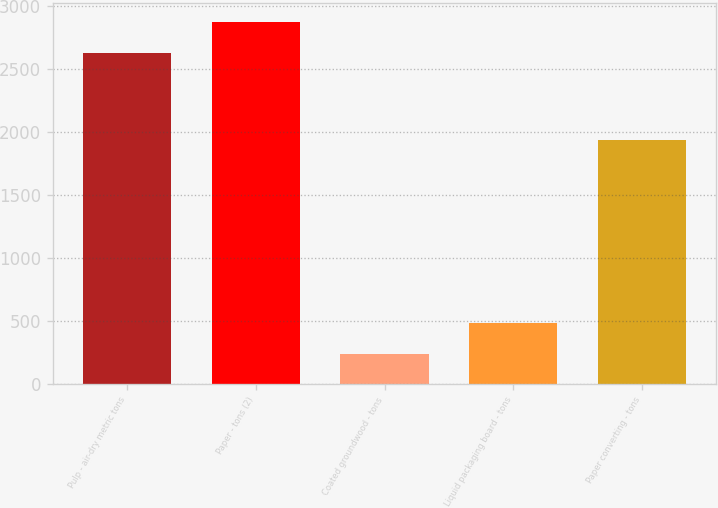Convert chart. <chart><loc_0><loc_0><loc_500><loc_500><bar_chart><fcel>Pulp - air-dry metric tons<fcel>Paper - tons (2)<fcel>Coated groundwood - tons<fcel>Liquid packaging board - tons<fcel>Paper converting - tons<nl><fcel>2621<fcel>2872.5<fcel>234<fcel>485.5<fcel>1932<nl></chart> 